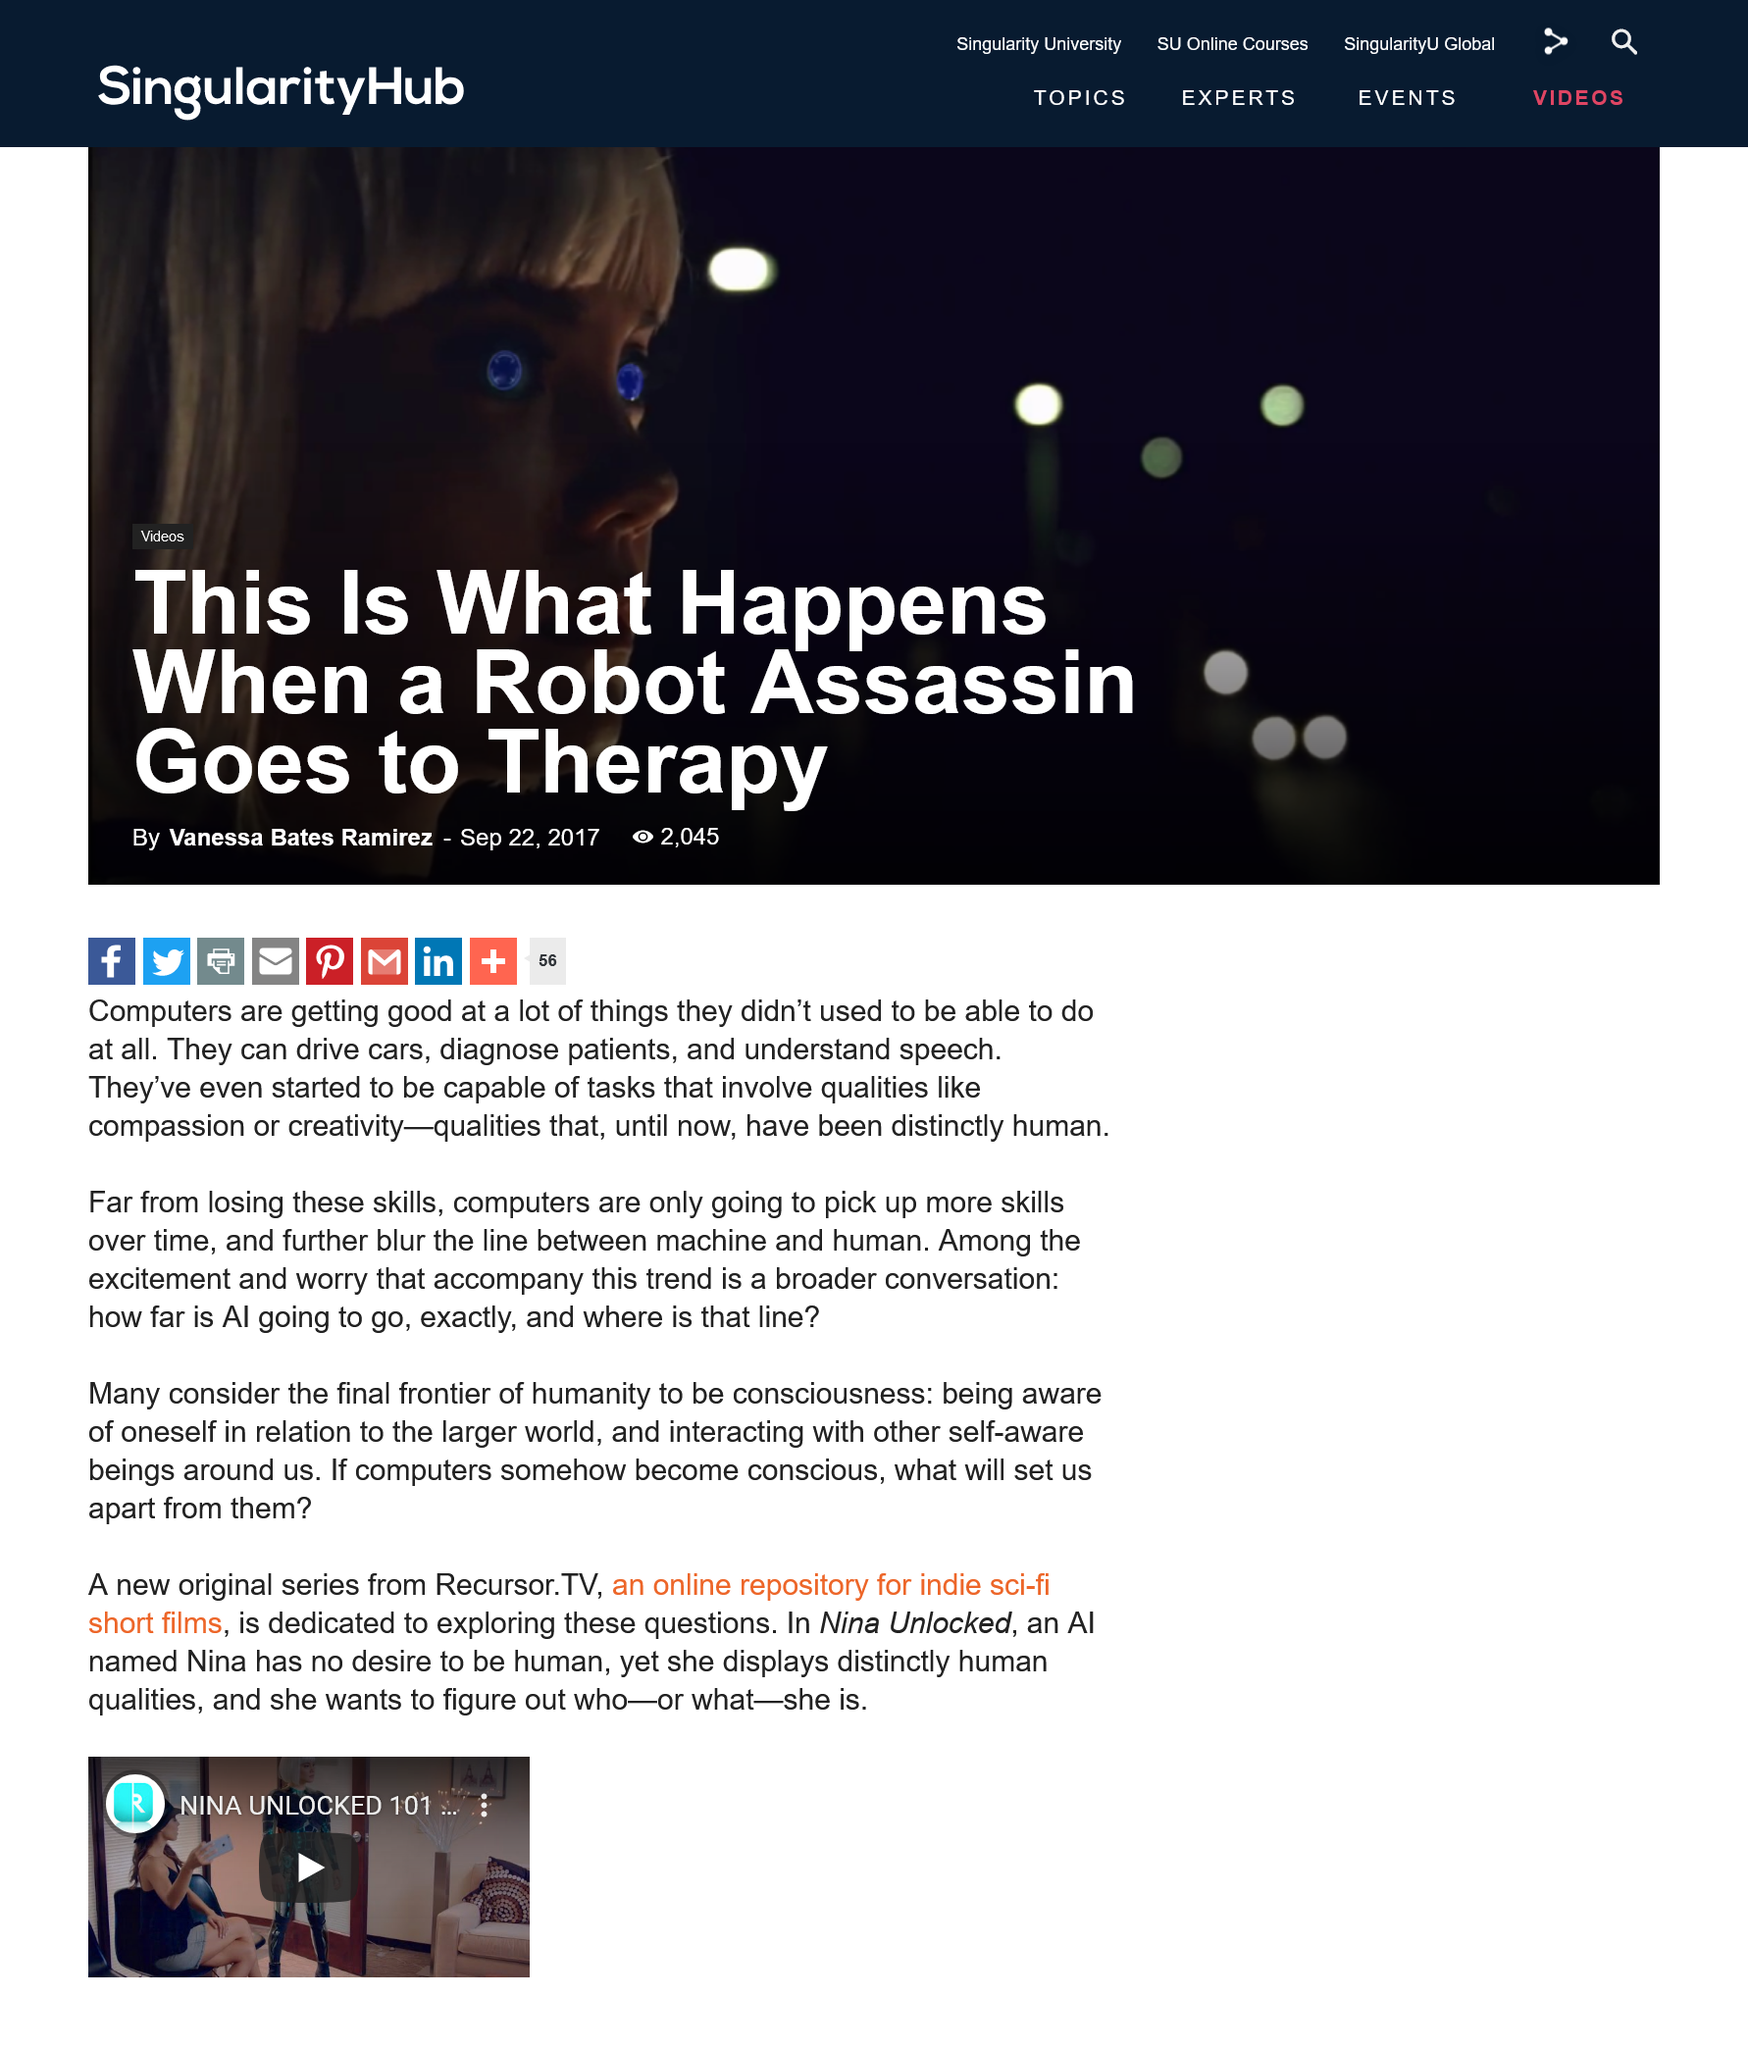Highlight a few significant elements in this photo. What is considered the final frontier by many? They consider it to be consciousness. Until now, human qualities such as compassion and creativity have been the only ones possessed by Sich, but this is about to change. The article was published in 2017. 